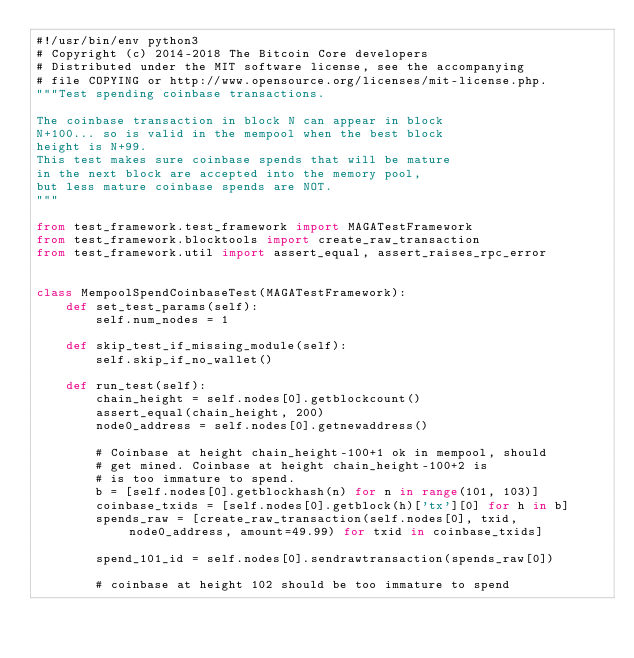<code> <loc_0><loc_0><loc_500><loc_500><_Python_>#!/usr/bin/env python3
# Copyright (c) 2014-2018 The Bitcoin Core developers
# Distributed under the MIT software license, see the accompanying
# file COPYING or http://www.opensource.org/licenses/mit-license.php.
"""Test spending coinbase transactions.

The coinbase transaction in block N can appear in block
N+100... so is valid in the mempool when the best block
height is N+99.
This test makes sure coinbase spends that will be mature
in the next block are accepted into the memory pool,
but less mature coinbase spends are NOT.
"""

from test_framework.test_framework import MAGATestFramework
from test_framework.blocktools import create_raw_transaction
from test_framework.util import assert_equal, assert_raises_rpc_error


class MempoolSpendCoinbaseTest(MAGATestFramework):
    def set_test_params(self):
        self.num_nodes = 1

    def skip_test_if_missing_module(self):
        self.skip_if_no_wallet()

    def run_test(self):
        chain_height = self.nodes[0].getblockcount()
        assert_equal(chain_height, 200)
        node0_address = self.nodes[0].getnewaddress()

        # Coinbase at height chain_height-100+1 ok in mempool, should
        # get mined. Coinbase at height chain_height-100+2 is
        # is too immature to spend.
        b = [self.nodes[0].getblockhash(n) for n in range(101, 103)]
        coinbase_txids = [self.nodes[0].getblock(h)['tx'][0] for h in b]
        spends_raw = [create_raw_transaction(self.nodes[0], txid, node0_address, amount=49.99) for txid in coinbase_txids]

        spend_101_id = self.nodes[0].sendrawtransaction(spends_raw[0])

        # coinbase at height 102 should be too immature to spend</code> 